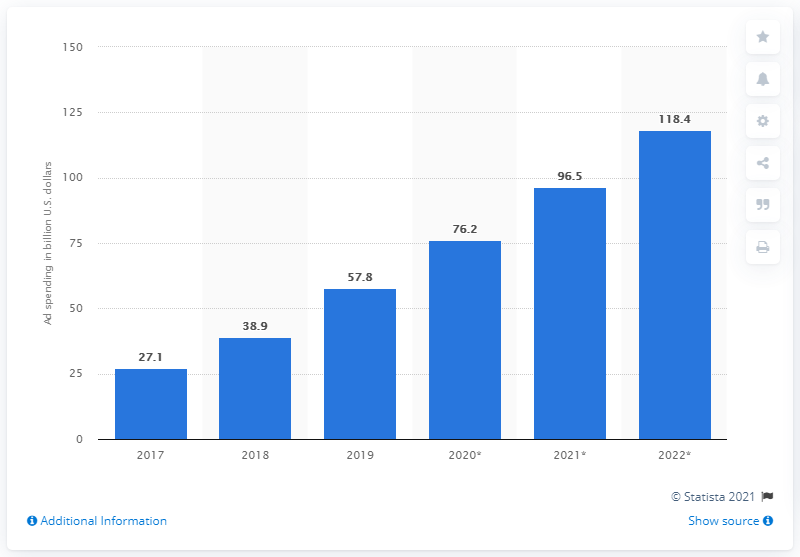Give some essential details in this illustration. The global app install advertising spend is expected to grow by the end of 2022 to 118.4 billion US dollars. In 2019, the amount of money spent on advertising to encourage app installs was 57.8 billion. 